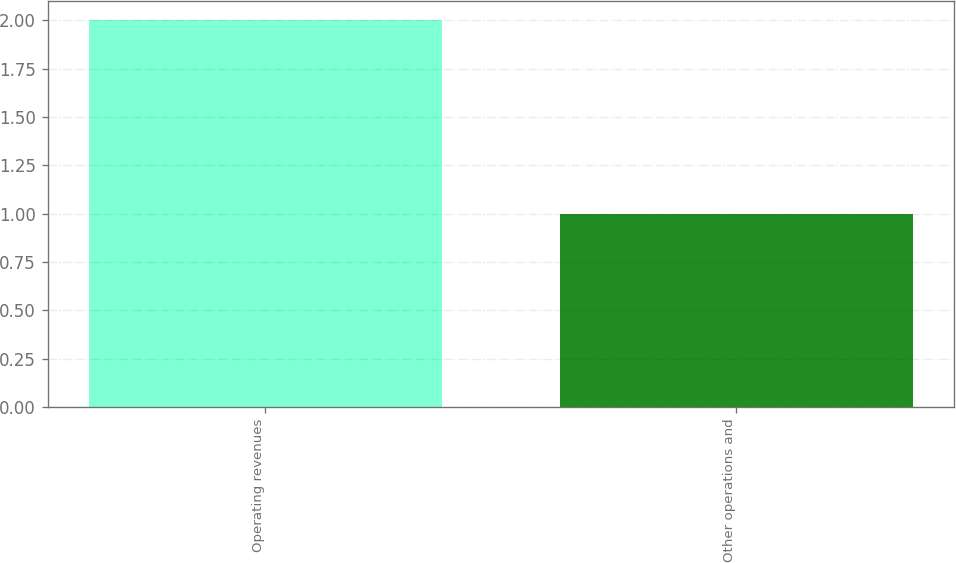Convert chart to OTSL. <chart><loc_0><loc_0><loc_500><loc_500><bar_chart><fcel>Operating revenues<fcel>Other operations and<nl><fcel>2<fcel>1<nl></chart> 